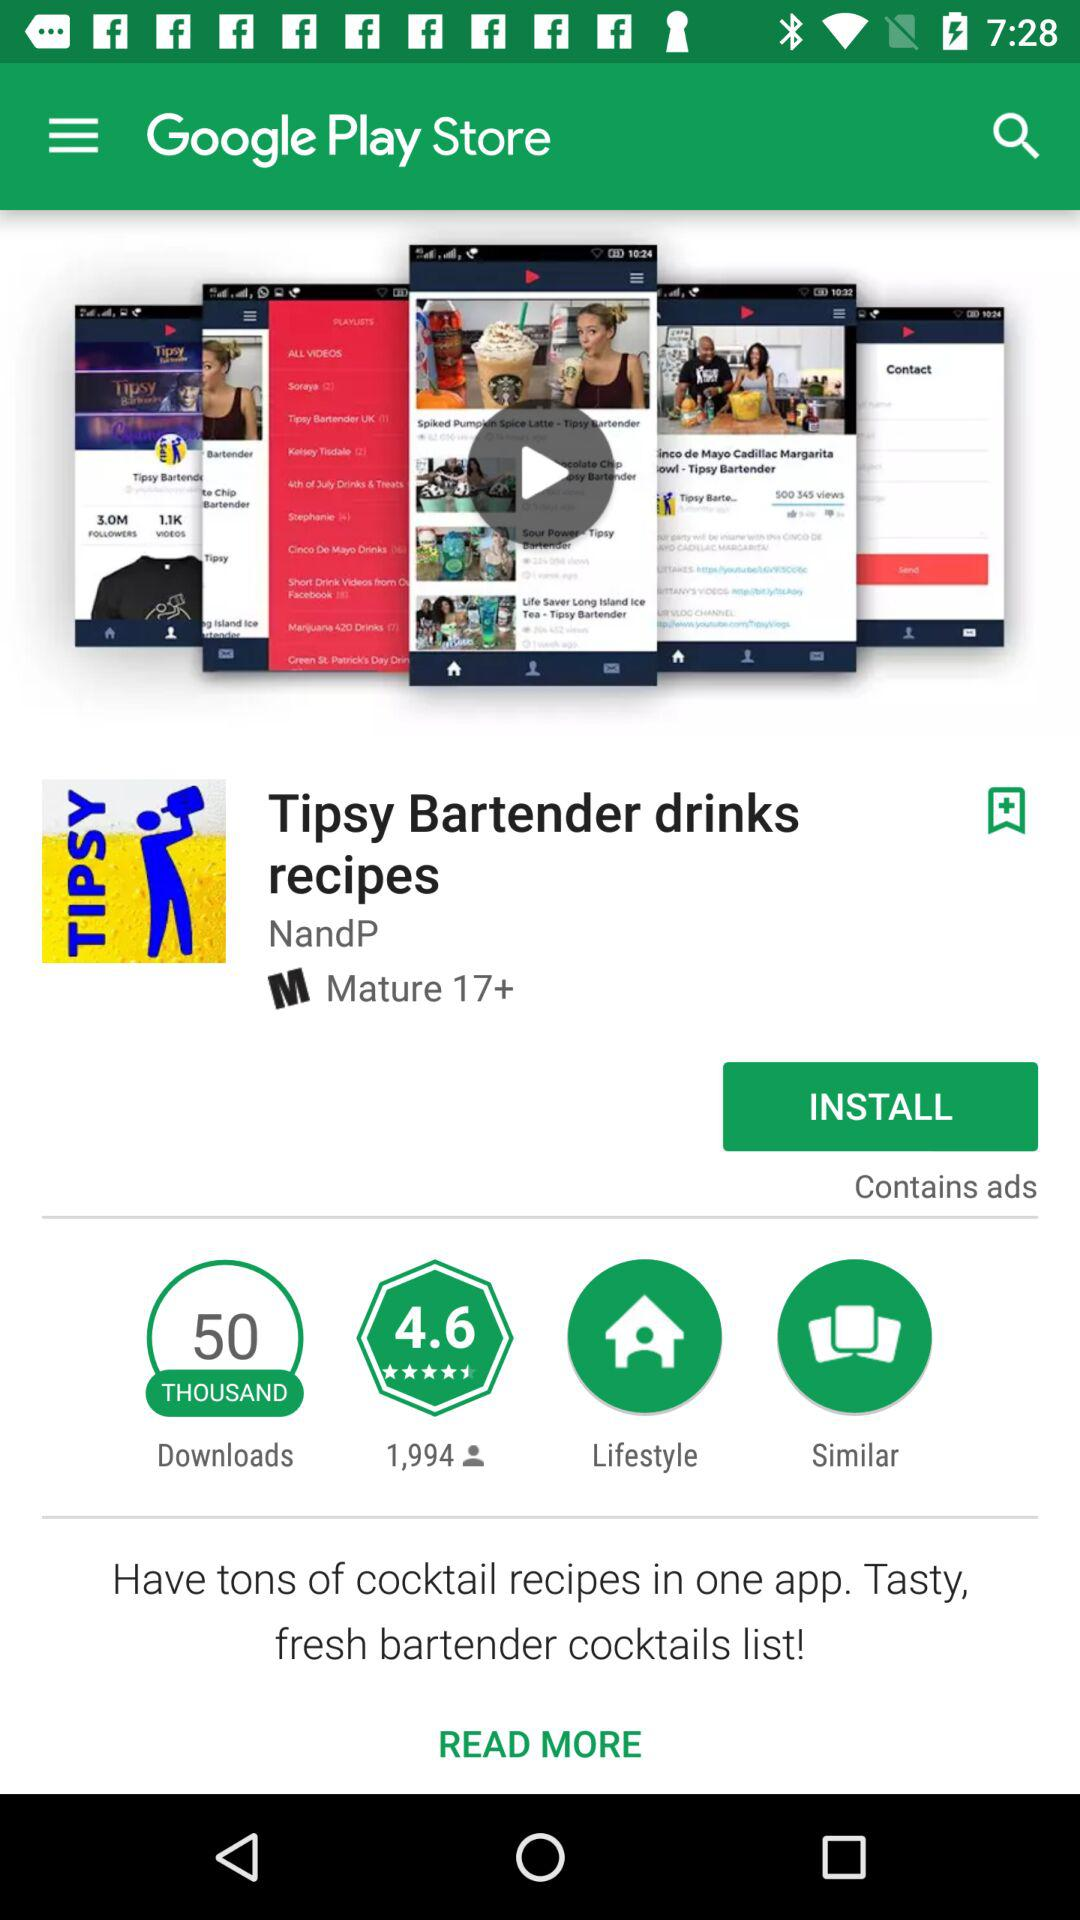How many people gave a rating to the application? The application got a rating from 1,994 people. 